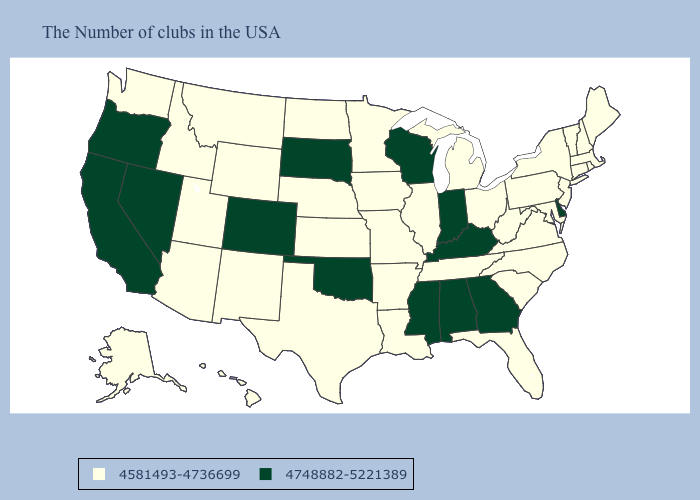What is the value of Arizona?
Short answer required. 4581493-4736699. What is the highest value in states that border Oklahoma?
Be succinct. 4748882-5221389. What is the value of Kansas?
Keep it brief. 4581493-4736699. What is the lowest value in states that border Connecticut?
Short answer required. 4581493-4736699. What is the lowest value in the Northeast?
Short answer required. 4581493-4736699. Which states have the highest value in the USA?
Be succinct. Delaware, Georgia, Kentucky, Indiana, Alabama, Wisconsin, Mississippi, Oklahoma, South Dakota, Colorado, Nevada, California, Oregon. Among the states that border South Carolina , which have the highest value?
Keep it brief. Georgia. What is the value of Wyoming?
Keep it brief. 4581493-4736699. Among the states that border Arkansas , which have the lowest value?
Give a very brief answer. Tennessee, Louisiana, Missouri, Texas. Does Idaho have the highest value in the USA?
Be succinct. No. What is the highest value in the South ?
Keep it brief. 4748882-5221389. Does the first symbol in the legend represent the smallest category?
Give a very brief answer. Yes. Does Vermont have a higher value than North Dakota?
Concise answer only. No. Name the states that have a value in the range 4748882-5221389?
Short answer required. Delaware, Georgia, Kentucky, Indiana, Alabama, Wisconsin, Mississippi, Oklahoma, South Dakota, Colorado, Nevada, California, Oregon. Does Tennessee have the lowest value in the USA?
Quick response, please. Yes. 